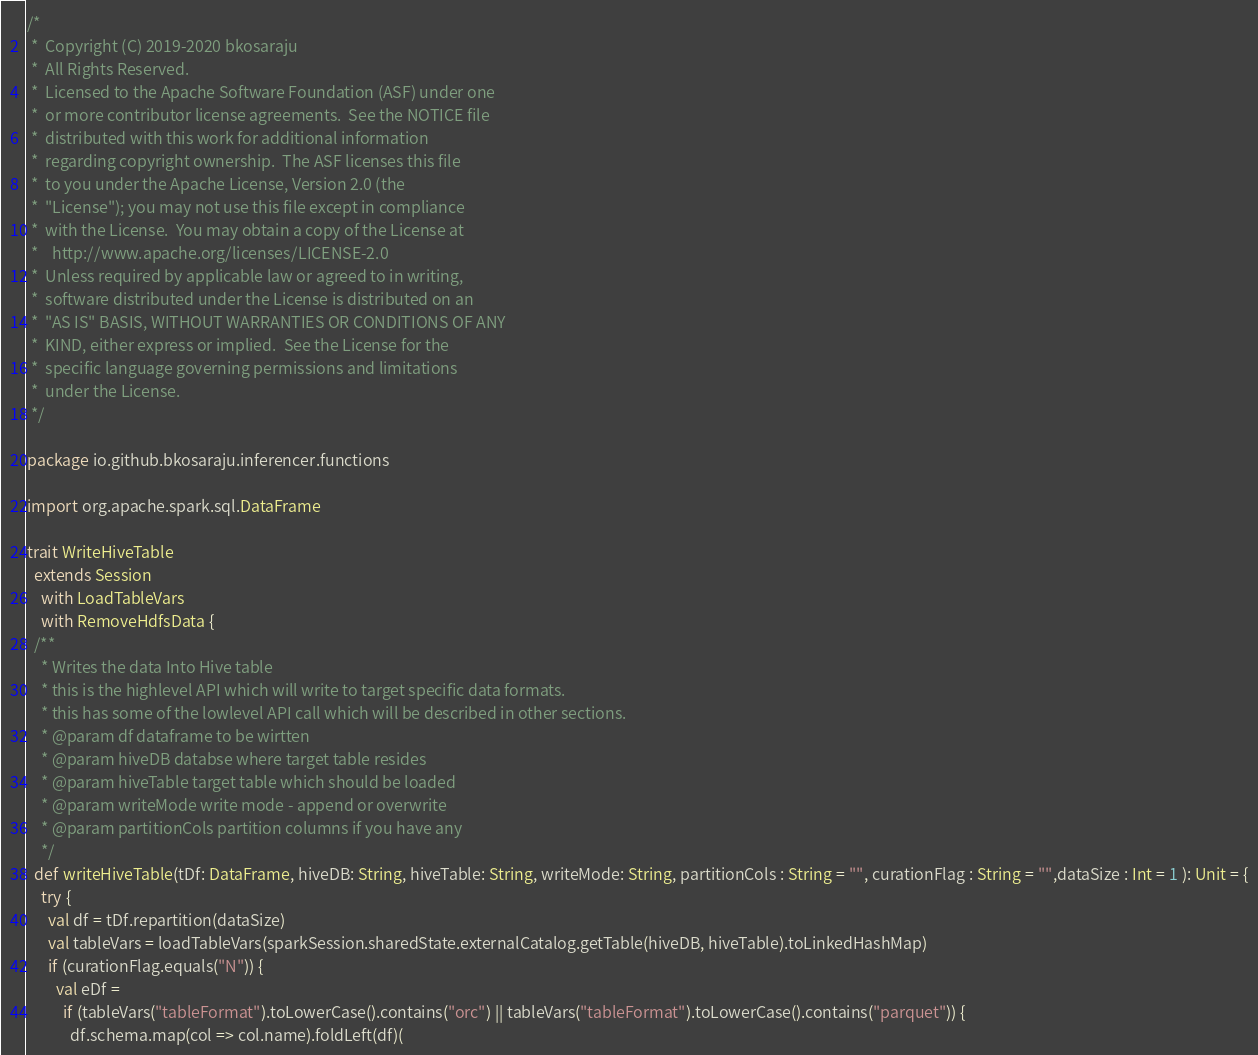Convert code to text. <code><loc_0><loc_0><loc_500><loc_500><_Scala_>/*
 *  Copyright (C) 2019-2020 bkosaraju
 *  All Rights Reserved.
 *  Licensed to the Apache Software Foundation (ASF) under one
 *  or more contributor license agreements.  See the NOTICE file
 *  distributed with this work for additional information
 *  regarding copyright ownership.  The ASF licenses this file
 *  to you under the Apache License, Version 2.0 (the
 *  "License"); you may not use this file except in compliance
 *  with the License.  You may obtain a copy of the License at
 *    http://www.apache.org/licenses/LICENSE-2.0
 *  Unless required by applicable law or agreed to in writing,
 *  software distributed under the License is distributed on an
 *  "AS IS" BASIS, WITHOUT WARRANTIES OR CONDITIONS OF ANY
 *  KIND, either express or implied.  See the License for the
 *  specific language governing permissions and limitations
 *  under the License.
 */

package io.github.bkosaraju.inferencer.functions

import org.apache.spark.sql.DataFrame

trait WriteHiveTable
  extends Session
    with LoadTableVars
    with RemoveHdfsData {
  /**
    * Writes the data Into Hive table
    * this is the highlevel API which will write to target specific data formats.
    * this has some of the lowlevel API call which will be described in other sections.
    * @param df dataframe to be wirtten
    * @param hiveDB databse where target table resides
    * @param hiveTable target table which should be loaded
    * @param writeMode write mode - append or overwrite
    * @param partitionCols partition columns if you have any
    */
  def writeHiveTable(tDf: DataFrame, hiveDB: String, hiveTable: String, writeMode: String, partitionCols : String = "", curationFlag : String = "",dataSize : Int = 1 ): Unit = {
    try {
      val df = tDf.repartition(dataSize)
      val tableVars = loadTableVars(sparkSession.sharedState.externalCatalog.getTable(hiveDB, hiveTable).toLinkedHashMap)
      if (curationFlag.equals("N")) {
        val eDf =
          if (tableVars("tableFormat").toLowerCase().contains("orc") || tableVars("tableFormat").toLowerCase().contains("parquet")) {
            df.schema.map(col => col.name).foldLeft(df)(</code> 